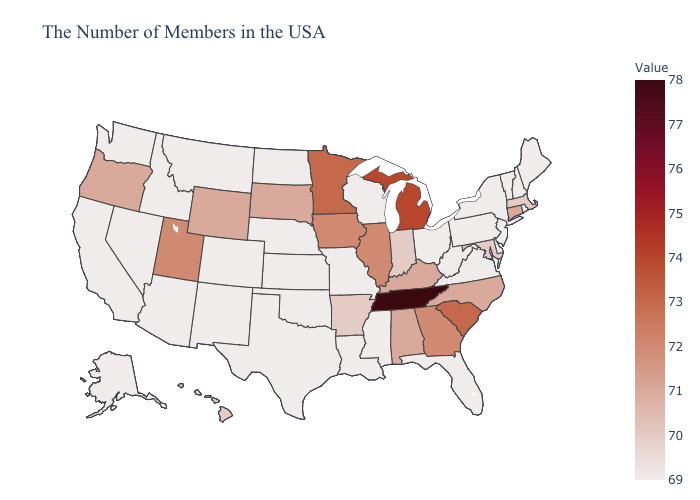Which states have the lowest value in the West?
Give a very brief answer. Colorado, New Mexico, Montana, Arizona, Idaho, Nevada, California, Washington, Alaska. Among the states that border Missouri , does Illinois have the lowest value?
Be succinct. No. Does Arizona have the lowest value in the USA?
Be succinct. Yes. Among the states that border Mississippi , which have the lowest value?
Be succinct. Louisiana. Among the states that border California , does Oregon have the highest value?
Quick response, please. Yes. 